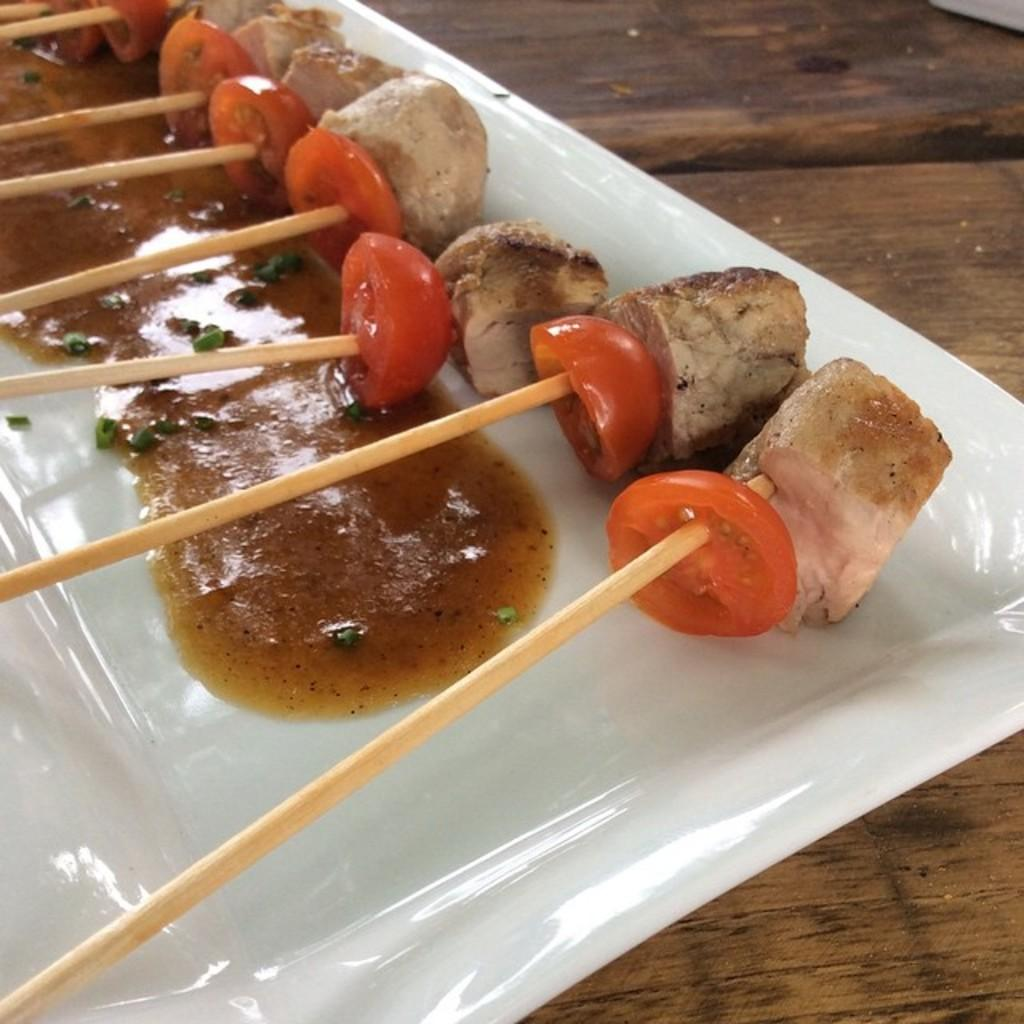What type of items can be seen in the image? There are food items in the image. Can you describe the specific food items on the plate? There are sticks on a plate in the image. What is the plate resting on? The plate is on a wooden surface. How many sisters are present in the image? There are no sisters present in the image; it only features food items, sticks, and a wooden surface. 